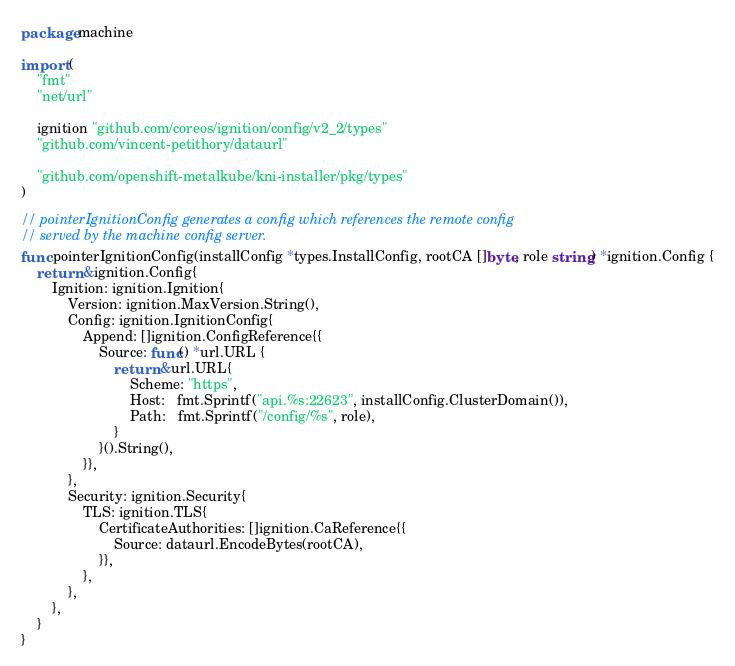Convert code to text. <code><loc_0><loc_0><loc_500><loc_500><_Go_>package machine

import (
	"fmt"
	"net/url"

	ignition "github.com/coreos/ignition/config/v2_2/types"
	"github.com/vincent-petithory/dataurl"

	"github.com/openshift-metalkube/kni-installer/pkg/types"
)

// pointerIgnitionConfig generates a config which references the remote config
// served by the machine config server.
func pointerIgnitionConfig(installConfig *types.InstallConfig, rootCA []byte, role string) *ignition.Config {
	return &ignition.Config{
		Ignition: ignition.Ignition{
			Version: ignition.MaxVersion.String(),
			Config: ignition.IgnitionConfig{
				Append: []ignition.ConfigReference{{
					Source: func() *url.URL {
						return &url.URL{
							Scheme: "https",
							Host:   fmt.Sprintf("api.%s:22623", installConfig.ClusterDomain()),
							Path:   fmt.Sprintf("/config/%s", role),
						}
					}().String(),
				}},
			},
			Security: ignition.Security{
				TLS: ignition.TLS{
					CertificateAuthorities: []ignition.CaReference{{
						Source: dataurl.EncodeBytes(rootCA),
					}},
				},
			},
		},
	}
}
</code> 